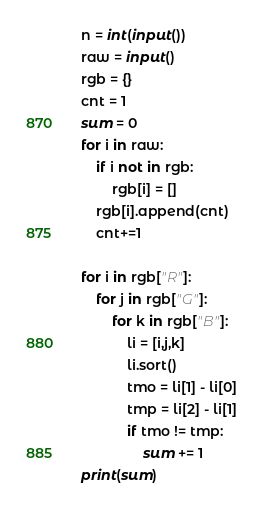Convert code to text. <code><loc_0><loc_0><loc_500><loc_500><_Python_>n = int(input())
raw = input()
rgb = {}
cnt = 1
sum = 0
for i in raw:
    if i not in rgb:
        rgb[i] = []
    rgb[i].append(cnt)
    cnt+=1

for i in rgb["R"]:
    for j in rgb["G"]:
        for k in rgb["B"]:
            li = [i,j,k]
            li.sort()
            tmo = li[1] - li[0]
            tmp = li[2] - li[1]
            if tmo != tmp:
                sum += 1
print(sum)</code> 